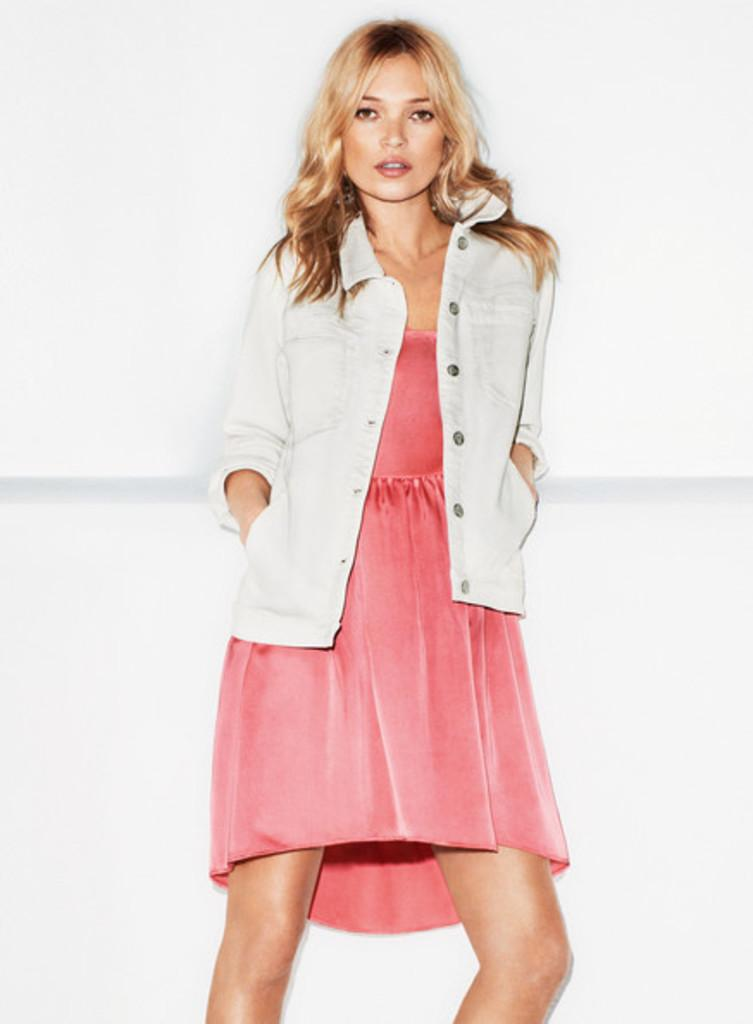What is the main subject of the image? There is a woman standing in the center of the image. Can you describe the background of the image? There is a wall visible in the background of the image. How many wings does the woman have in the image? The woman does not have any wings in the image. What type of tax is being discussed in the image? There is no discussion of tax in the image. 